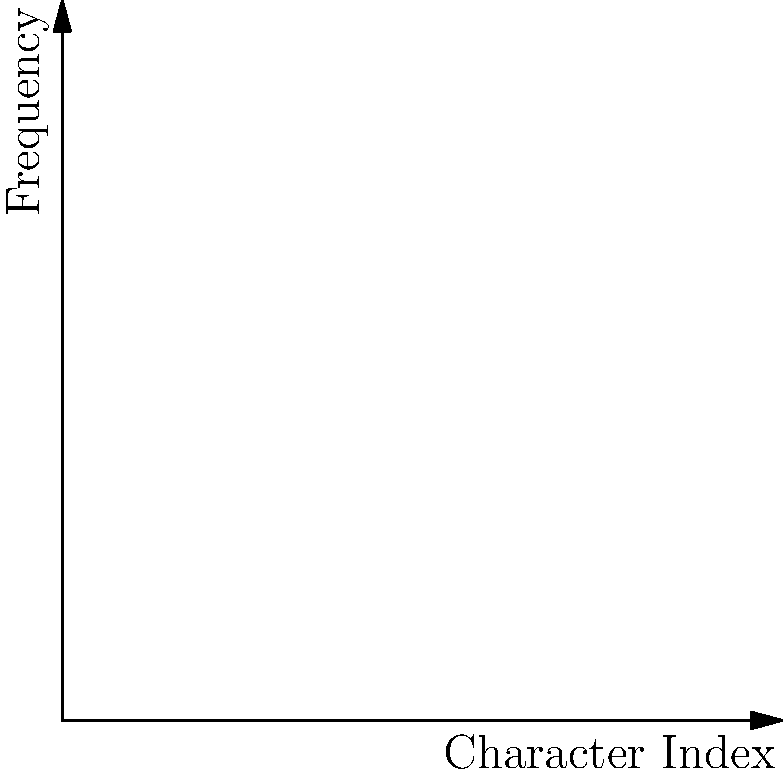In the 2D histogram representing the frequency distribution of encrypted characters, what is the index of the character with the highest frequency, and what potential weakness in the encryption method does this peak suggest? To answer this question, we need to analyze the 2D histogram:

1. The x-axis represents the character index (0-9), and the y-axis represents the frequency of occurrence.

2. Examine each bar in the histogram to find the tallest one:
   - Index 0: height ≈ 2
   - Index 1: height ≈ 5
   - Index 2: height ≈ 8
   - Index 3: height ≈ 3
   - Index 4: height ≈ 7
   - Index 5: height ≈ 4
   - Index 6: height ≈ 6
   - Index 7: height ≈ 1
   - Index 8: height ≈ 9 (highest)
   - Index 9: height ≈ 2

3. The tallest bar is at index 8, with a frequency of 9.

4. This peak suggests a potential weakness in the encryption method:
   - In a strong encryption, we expect a relatively uniform distribution of characters.
   - A significant peak indicates that a particular character appears much more frequently than others.
   - This non-uniform distribution can be exploited using frequency analysis techniques to guess the original character.

5. The weakness implied is that the encryption method may not sufficiently mask the underlying frequency patterns of the plaintext, making it potentially vulnerable to statistical attacks.
Answer: Index 8; non-uniform character distribution vulnerable to frequency analysis 